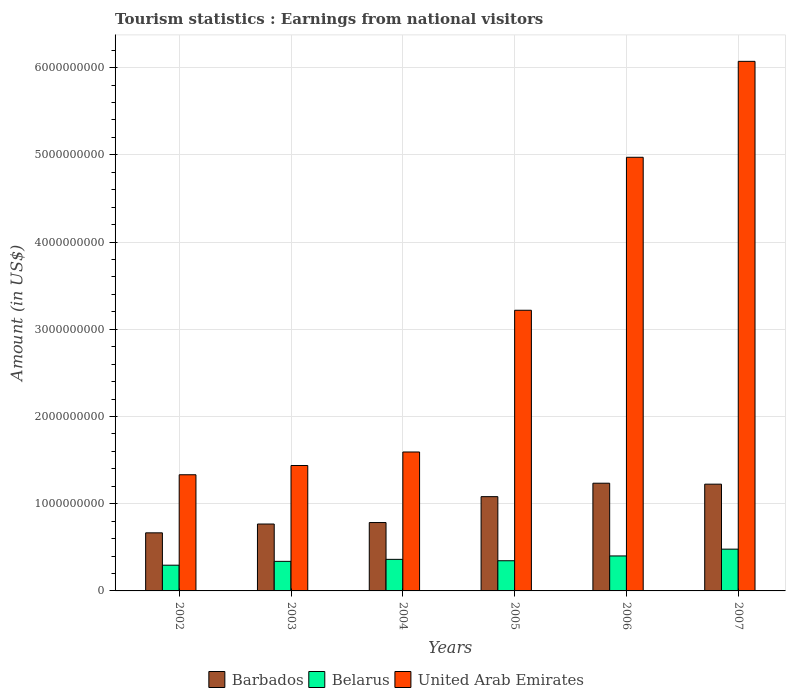How many groups of bars are there?
Give a very brief answer. 6. How many bars are there on the 6th tick from the right?
Offer a terse response. 3. What is the label of the 6th group of bars from the left?
Make the answer very short. 2007. In how many cases, is the number of bars for a given year not equal to the number of legend labels?
Provide a succinct answer. 0. What is the earnings from national visitors in United Arab Emirates in 2004?
Offer a terse response. 1.59e+09. Across all years, what is the maximum earnings from national visitors in Belarus?
Keep it short and to the point. 4.79e+08. Across all years, what is the minimum earnings from national visitors in United Arab Emirates?
Ensure brevity in your answer.  1.33e+09. What is the total earnings from national visitors in United Arab Emirates in the graph?
Make the answer very short. 1.86e+1. What is the difference between the earnings from national visitors in Barbados in 2002 and that in 2005?
Ensure brevity in your answer.  -4.15e+08. What is the difference between the earnings from national visitors in Barbados in 2007 and the earnings from national visitors in Belarus in 2005?
Your answer should be compact. 8.78e+08. What is the average earnings from national visitors in Belarus per year?
Give a very brief answer. 3.70e+08. In the year 2005, what is the difference between the earnings from national visitors in Belarus and earnings from national visitors in United Arab Emirates?
Your answer should be very brief. -2.87e+09. What is the ratio of the earnings from national visitors in United Arab Emirates in 2004 to that in 2007?
Your answer should be very brief. 0.26. Is the earnings from national visitors in United Arab Emirates in 2002 less than that in 2007?
Ensure brevity in your answer.  Yes. Is the difference between the earnings from national visitors in Belarus in 2003 and 2005 greater than the difference between the earnings from national visitors in United Arab Emirates in 2003 and 2005?
Make the answer very short. Yes. What is the difference between the highest and the second highest earnings from national visitors in Belarus?
Your response must be concise. 7.80e+07. What is the difference between the highest and the lowest earnings from national visitors in United Arab Emirates?
Your response must be concise. 4.74e+09. In how many years, is the earnings from national visitors in Belarus greater than the average earnings from national visitors in Belarus taken over all years?
Your answer should be very brief. 2. Is the sum of the earnings from national visitors in Barbados in 2004 and 2007 greater than the maximum earnings from national visitors in United Arab Emirates across all years?
Provide a short and direct response. No. What does the 3rd bar from the left in 2007 represents?
Your answer should be very brief. United Arab Emirates. What does the 2nd bar from the right in 2003 represents?
Keep it short and to the point. Belarus. How many years are there in the graph?
Make the answer very short. 6. What is the difference between two consecutive major ticks on the Y-axis?
Offer a very short reply. 1.00e+09. Are the values on the major ticks of Y-axis written in scientific E-notation?
Offer a very short reply. No. Does the graph contain any zero values?
Provide a succinct answer. No. Does the graph contain grids?
Your answer should be compact. Yes. Where does the legend appear in the graph?
Ensure brevity in your answer.  Bottom center. How many legend labels are there?
Offer a terse response. 3. How are the legend labels stacked?
Your answer should be compact. Horizontal. What is the title of the graph?
Provide a succinct answer. Tourism statistics : Earnings from national visitors. What is the Amount (in US$) of Barbados in 2002?
Provide a short and direct response. 6.66e+08. What is the Amount (in US$) of Belarus in 2002?
Ensure brevity in your answer.  2.95e+08. What is the Amount (in US$) in United Arab Emirates in 2002?
Offer a very short reply. 1.33e+09. What is the Amount (in US$) of Barbados in 2003?
Keep it short and to the point. 7.67e+08. What is the Amount (in US$) of Belarus in 2003?
Offer a terse response. 3.39e+08. What is the Amount (in US$) in United Arab Emirates in 2003?
Your response must be concise. 1.44e+09. What is the Amount (in US$) in Barbados in 2004?
Give a very brief answer. 7.84e+08. What is the Amount (in US$) in Belarus in 2004?
Your answer should be compact. 3.62e+08. What is the Amount (in US$) of United Arab Emirates in 2004?
Offer a terse response. 1.59e+09. What is the Amount (in US$) in Barbados in 2005?
Make the answer very short. 1.08e+09. What is the Amount (in US$) of Belarus in 2005?
Your answer should be very brief. 3.46e+08. What is the Amount (in US$) of United Arab Emirates in 2005?
Your response must be concise. 3.22e+09. What is the Amount (in US$) of Barbados in 2006?
Provide a succinct answer. 1.24e+09. What is the Amount (in US$) of Belarus in 2006?
Your answer should be compact. 4.01e+08. What is the Amount (in US$) in United Arab Emirates in 2006?
Provide a short and direct response. 4.97e+09. What is the Amount (in US$) of Barbados in 2007?
Your response must be concise. 1.22e+09. What is the Amount (in US$) in Belarus in 2007?
Your answer should be compact. 4.79e+08. What is the Amount (in US$) in United Arab Emirates in 2007?
Give a very brief answer. 6.07e+09. Across all years, what is the maximum Amount (in US$) of Barbados?
Provide a succinct answer. 1.24e+09. Across all years, what is the maximum Amount (in US$) in Belarus?
Ensure brevity in your answer.  4.79e+08. Across all years, what is the maximum Amount (in US$) in United Arab Emirates?
Make the answer very short. 6.07e+09. Across all years, what is the minimum Amount (in US$) of Barbados?
Offer a very short reply. 6.66e+08. Across all years, what is the minimum Amount (in US$) of Belarus?
Offer a terse response. 2.95e+08. Across all years, what is the minimum Amount (in US$) in United Arab Emirates?
Your answer should be very brief. 1.33e+09. What is the total Amount (in US$) of Barbados in the graph?
Your answer should be compact. 5.76e+09. What is the total Amount (in US$) of Belarus in the graph?
Ensure brevity in your answer.  2.22e+09. What is the total Amount (in US$) of United Arab Emirates in the graph?
Give a very brief answer. 1.86e+1. What is the difference between the Amount (in US$) in Barbados in 2002 and that in 2003?
Keep it short and to the point. -1.01e+08. What is the difference between the Amount (in US$) of Belarus in 2002 and that in 2003?
Your response must be concise. -4.40e+07. What is the difference between the Amount (in US$) of United Arab Emirates in 2002 and that in 2003?
Make the answer very short. -1.06e+08. What is the difference between the Amount (in US$) in Barbados in 2002 and that in 2004?
Provide a succinct answer. -1.18e+08. What is the difference between the Amount (in US$) of Belarus in 2002 and that in 2004?
Give a very brief answer. -6.70e+07. What is the difference between the Amount (in US$) in United Arab Emirates in 2002 and that in 2004?
Keep it short and to the point. -2.61e+08. What is the difference between the Amount (in US$) in Barbados in 2002 and that in 2005?
Your answer should be very brief. -4.15e+08. What is the difference between the Amount (in US$) of Belarus in 2002 and that in 2005?
Provide a short and direct response. -5.10e+07. What is the difference between the Amount (in US$) of United Arab Emirates in 2002 and that in 2005?
Your response must be concise. -1.89e+09. What is the difference between the Amount (in US$) of Barbados in 2002 and that in 2006?
Keep it short and to the point. -5.69e+08. What is the difference between the Amount (in US$) in Belarus in 2002 and that in 2006?
Ensure brevity in your answer.  -1.06e+08. What is the difference between the Amount (in US$) of United Arab Emirates in 2002 and that in 2006?
Your response must be concise. -3.64e+09. What is the difference between the Amount (in US$) in Barbados in 2002 and that in 2007?
Offer a very short reply. -5.58e+08. What is the difference between the Amount (in US$) of Belarus in 2002 and that in 2007?
Provide a short and direct response. -1.84e+08. What is the difference between the Amount (in US$) in United Arab Emirates in 2002 and that in 2007?
Offer a very short reply. -4.74e+09. What is the difference between the Amount (in US$) of Barbados in 2003 and that in 2004?
Ensure brevity in your answer.  -1.70e+07. What is the difference between the Amount (in US$) of Belarus in 2003 and that in 2004?
Your answer should be compact. -2.30e+07. What is the difference between the Amount (in US$) in United Arab Emirates in 2003 and that in 2004?
Your answer should be compact. -1.55e+08. What is the difference between the Amount (in US$) of Barbados in 2003 and that in 2005?
Make the answer very short. -3.14e+08. What is the difference between the Amount (in US$) of Belarus in 2003 and that in 2005?
Make the answer very short. -7.00e+06. What is the difference between the Amount (in US$) in United Arab Emirates in 2003 and that in 2005?
Give a very brief answer. -1.78e+09. What is the difference between the Amount (in US$) in Barbados in 2003 and that in 2006?
Your answer should be very brief. -4.68e+08. What is the difference between the Amount (in US$) in Belarus in 2003 and that in 2006?
Offer a terse response. -6.20e+07. What is the difference between the Amount (in US$) of United Arab Emirates in 2003 and that in 2006?
Provide a short and direct response. -3.53e+09. What is the difference between the Amount (in US$) of Barbados in 2003 and that in 2007?
Provide a succinct answer. -4.57e+08. What is the difference between the Amount (in US$) of Belarus in 2003 and that in 2007?
Provide a short and direct response. -1.40e+08. What is the difference between the Amount (in US$) of United Arab Emirates in 2003 and that in 2007?
Ensure brevity in your answer.  -4.63e+09. What is the difference between the Amount (in US$) of Barbados in 2004 and that in 2005?
Offer a terse response. -2.97e+08. What is the difference between the Amount (in US$) of Belarus in 2004 and that in 2005?
Provide a short and direct response. 1.60e+07. What is the difference between the Amount (in US$) of United Arab Emirates in 2004 and that in 2005?
Your response must be concise. -1.62e+09. What is the difference between the Amount (in US$) of Barbados in 2004 and that in 2006?
Keep it short and to the point. -4.51e+08. What is the difference between the Amount (in US$) of Belarus in 2004 and that in 2006?
Your response must be concise. -3.90e+07. What is the difference between the Amount (in US$) of United Arab Emirates in 2004 and that in 2006?
Your answer should be very brief. -3.38e+09. What is the difference between the Amount (in US$) of Barbados in 2004 and that in 2007?
Your response must be concise. -4.40e+08. What is the difference between the Amount (in US$) in Belarus in 2004 and that in 2007?
Make the answer very short. -1.17e+08. What is the difference between the Amount (in US$) of United Arab Emirates in 2004 and that in 2007?
Ensure brevity in your answer.  -4.48e+09. What is the difference between the Amount (in US$) of Barbados in 2005 and that in 2006?
Your response must be concise. -1.54e+08. What is the difference between the Amount (in US$) in Belarus in 2005 and that in 2006?
Provide a succinct answer. -5.50e+07. What is the difference between the Amount (in US$) of United Arab Emirates in 2005 and that in 2006?
Your answer should be compact. -1.75e+09. What is the difference between the Amount (in US$) of Barbados in 2005 and that in 2007?
Make the answer very short. -1.43e+08. What is the difference between the Amount (in US$) in Belarus in 2005 and that in 2007?
Make the answer very short. -1.33e+08. What is the difference between the Amount (in US$) in United Arab Emirates in 2005 and that in 2007?
Provide a short and direct response. -2.85e+09. What is the difference between the Amount (in US$) in Barbados in 2006 and that in 2007?
Ensure brevity in your answer.  1.10e+07. What is the difference between the Amount (in US$) in Belarus in 2006 and that in 2007?
Keep it short and to the point. -7.80e+07. What is the difference between the Amount (in US$) of United Arab Emirates in 2006 and that in 2007?
Offer a terse response. -1.10e+09. What is the difference between the Amount (in US$) in Barbados in 2002 and the Amount (in US$) in Belarus in 2003?
Offer a very short reply. 3.27e+08. What is the difference between the Amount (in US$) in Barbados in 2002 and the Amount (in US$) in United Arab Emirates in 2003?
Keep it short and to the point. -7.72e+08. What is the difference between the Amount (in US$) in Belarus in 2002 and the Amount (in US$) in United Arab Emirates in 2003?
Give a very brief answer. -1.14e+09. What is the difference between the Amount (in US$) of Barbados in 2002 and the Amount (in US$) of Belarus in 2004?
Keep it short and to the point. 3.04e+08. What is the difference between the Amount (in US$) in Barbados in 2002 and the Amount (in US$) in United Arab Emirates in 2004?
Ensure brevity in your answer.  -9.27e+08. What is the difference between the Amount (in US$) of Belarus in 2002 and the Amount (in US$) of United Arab Emirates in 2004?
Provide a short and direct response. -1.30e+09. What is the difference between the Amount (in US$) in Barbados in 2002 and the Amount (in US$) in Belarus in 2005?
Ensure brevity in your answer.  3.20e+08. What is the difference between the Amount (in US$) in Barbados in 2002 and the Amount (in US$) in United Arab Emirates in 2005?
Provide a short and direct response. -2.55e+09. What is the difference between the Amount (in US$) of Belarus in 2002 and the Amount (in US$) of United Arab Emirates in 2005?
Give a very brief answer. -2.92e+09. What is the difference between the Amount (in US$) of Barbados in 2002 and the Amount (in US$) of Belarus in 2006?
Your answer should be very brief. 2.65e+08. What is the difference between the Amount (in US$) in Barbados in 2002 and the Amount (in US$) in United Arab Emirates in 2006?
Your response must be concise. -4.31e+09. What is the difference between the Amount (in US$) in Belarus in 2002 and the Amount (in US$) in United Arab Emirates in 2006?
Provide a succinct answer. -4.68e+09. What is the difference between the Amount (in US$) in Barbados in 2002 and the Amount (in US$) in Belarus in 2007?
Provide a succinct answer. 1.87e+08. What is the difference between the Amount (in US$) in Barbados in 2002 and the Amount (in US$) in United Arab Emirates in 2007?
Provide a succinct answer. -5.41e+09. What is the difference between the Amount (in US$) in Belarus in 2002 and the Amount (in US$) in United Arab Emirates in 2007?
Your answer should be compact. -5.78e+09. What is the difference between the Amount (in US$) of Barbados in 2003 and the Amount (in US$) of Belarus in 2004?
Make the answer very short. 4.05e+08. What is the difference between the Amount (in US$) of Barbados in 2003 and the Amount (in US$) of United Arab Emirates in 2004?
Give a very brief answer. -8.26e+08. What is the difference between the Amount (in US$) in Belarus in 2003 and the Amount (in US$) in United Arab Emirates in 2004?
Your answer should be compact. -1.25e+09. What is the difference between the Amount (in US$) of Barbados in 2003 and the Amount (in US$) of Belarus in 2005?
Make the answer very short. 4.21e+08. What is the difference between the Amount (in US$) of Barbados in 2003 and the Amount (in US$) of United Arab Emirates in 2005?
Offer a terse response. -2.45e+09. What is the difference between the Amount (in US$) of Belarus in 2003 and the Amount (in US$) of United Arab Emirates in 2005?
Make the answer very short. -2.88e+09. What is the difference between the Amount (in US$) in Barbados in 2003 and the Amount (in US$) in Belarus in 2006?
Your answer should be very brief. 3.66e+08. What is the difference between the Amount (in US$) of Barbados in 2003 and the Amount (in US$) of United Arab Emirates in 2006?
Keep it short and to the point. -4.20e+09. What is the difference between the Amount (in US$) of Belarus in 2003 and the Amount (in US$) of United Arab Emirates in 2006?
Provide a short and direct response. -4.63e+09. What is the difference between the Amount (in US$) in Barbados in 2003 and the Amount (in US$) in Belarus in 2007?
Offer a terse response. 2.88e+08. What is the difference between the Amount (in US$) in Barbados in 2003 and the Amount (in US$) in United Arab Emirates in 2007?
Offer a terse response. -5.30e+09. What is the difference between the Amount (in US$) in Belarus in 2003 and the Amount (in US$) in United Arab Emirates in 2007?
Offer a very short reply. -5.73e+09. What is the difference between the Amount (in US$) in Barbados in 2004 and the Amount (in US$) in Belarus in 2005?
Make the answer very short. 4.38e+08. What is the difference between the Amount (in US$) in Barbados in 2004 and the Amount (in US$) in United Arab Emirates in 2005?
Offer a terse response. -2.43e+09. What is the difference between the Amount (in US$) in Belarus in 2004 and the Amount (in US$) in United Arab Emirates in 2005?
Keep it short and to the point. -2.86e+09. What is the difference between the Amount (in US$) in Barbados in 2004 and the Amount (in US$) in Belarus in 2006?
Provide a succinct answer. 3.83e+08. What is the difference between the Amount (in US$) of Barbados in 2004 and the Amount (in US$) of United Arab Emirates in 2006?
Provide a succinct answer. -4.19e+09. What is the difference between the Amount (in US$) of Belarus in 2004 and the Amount (in US$) of United Arab Emirates in 2006?
Your answer should be compact. -4.61e+09. What is the difference between the Amount (in US$) of Barbados in 2004 and the Amount (in US$) of Belarus in 2007?
Give a very brief answer. 3.05e+08. What is the difference between the Amount (in US$) in Barbados in 2004 and the Amount (in US$) in United Arab Emirates in 2007?
Offer a very short reply. -5.29e+09. What is the difference between the Amount (in US$) in Belarus in 2004 and the Amount (in US$) in United Arab Emirates in 2007?
Keep it short and to the point. -5.71e+09. What is the difference between the Amount (in US$) of Barbados in 2005 and the Amount (in US$) of Belarus in 2006?
Provide a short and direct response. 6.80e+08. What is the difference between the Amount (in US$) of Barbados in 2005 and the Amount (in US$) of United Arab Emirates in 2006?
Make the answer very short. -3.89e+09. What is the difference between the Amount (in US$) in Belarus in 2005 and the Amount (in US$) in United Arab Emirates in 2006?
Provide a succinct answer. -4.63e+09. What is the difference between the Amount (in US$) in Barbados in 2005 and the Amount (in US$) in Belarus in 2007?
Offer a very short reply. 6.02e+08. What is the difference between the Amount (in US$) of Barbados in 2005 and the Amount (in US$) of United Arab Emirates in 2007?
Make the answer very short. -4.99e+09. What is the difference between the Amount (in US$) in Belarus in 2005 and the Amount (in US$) in United Arab Emirates in 2007?
Your answer should be very brief. -5.73e+09. What is the difference between the Amount (in US$) in Barbados in 2006 and the Amount (in US$) in Belarus in 2007?
Provide a short and direct response. 7.56e+08. What is the difference between the Amount (in US$) in Barbados in 2006 and the Amount (in US$) in United Arab Emirates in 2007?
Give a very brief answer. -4.84e+09. What is the difference between the Amount (in US$) in Belarus in 2006 and the Amount (in US$) in United Arab Emirates in 2007?
Offer a terse response. -5.67e+09. What is the average Amount (in US$) of Barbados per year?
Your response must be concise. 9.60e+08. What is the average Amount (in US$) in Belarus per year?
Keep it short and to the point. 3.70e+08. What is the average Amount (in US$) in United Arab Emirates per year?
Give a very brief answer. 3.10e+09. In the year 2002, what is the difference between the Amount (in US$) in Barbados and Amount (in US$) in Belarus?
Offer a terse response. 3.71e+08. In the year 2002, what is the difference between the Amount (in US$) of Barbados and Amount (in US$) of United Arab Emirates?
Offer a terse response. -6.66e+08. In the year 2002, what is the difference between the Amount (in US$) in Belarus and Amount (in US$) in United Arab Emirates?
Give a very brief answer. -1.04e+09. In the year 2003, what is the difference between the Amount (in US$) in Barbados and Amount (in US$) in Belarus?
Your answer should be very brief. 4.28e+08. In the year 2003, what is the difference between the Amount (in US$) in Barbados and Amount (in US$) in United Arab Emirates?
Provide a succinct answer. -6.71e+08. In the year 2003, what is the difference between the Amount (in US$) of Belarus and Amount (in US$) of United Arab Emirates?
Make the answer very short. -1.10e+09. In the year 2004, what is the difference between the Amount (in US$) of Barbados and Amount (in US$) of Belarus?
Your answer should be compact. 4.22e+08. In the year 2004, what is the difference between the Amount (in US$) in Barbados and Amount (in US$) in United Arab Emirates?
Make the answer very short. -8.09e+08. In the year 2004, what is the difference between the Amount (in US$) of Belarus and Amount (in US$) of United Arab Emirates?
Your response must be concise. -1.23e+09. In the year 2005, what is the difference between the Amount (in US$) of Barbados and Amount (in US$) of Belarus?
Your response must be concise. 7.35e+08. In the year 2005, what is the difference between the Amount (in US$) in Barbados and Amount (in US$) in United Arab Emirates?
Give a very brief answer. -2.14e+09. In the year 2005, what is the difference between the Amount (in US$) of Belarus and Amount (in US$) of United Arab Emirates?
Make the answer very short. -2.87e+09. In the year 2006, what is the difference between the Amount (in US$) in Barbados and Amount (in US$) in Belarus?
Offer a very short reply. 8.34e+08. In the year 2006, what is the difference between the Amount (in US$) in Barbados and Amount (in US$) in United Arab Emirates?
Offer a terse response. -3.74e+09. In the year 2006, what is the difference between the Amount (in US$) in Belarus and Amount (in US$) in United Arab Emirates?
Offer a terse response. -4.57e+09. In the year 2007, what is the difference between the Amount (in US$) of Barbados and Amount (in US$) of Belarus?
Your answer should be compact. 7.45e+08. In the year 2007, what is the difference between the Amount (in US$) in Barbados and Amount (in US$) in United Arab Emirates?
Make the answer very short. -4.85e+09. In the year 2007, what is the difference between the Amount (in US$) of Belarus and Amount (in US$) of United Arab Emirates?
Keep it short and to the point. -5.59e+09. What is the ratio of the Amount (in US$) in Barbados in 2002 to that in 2003?
Provide a short and direct response. 0.87. What is the ratio of the Amount (in US$) in Belarus in 2002 to that in 2003?
Keep it short and to the point. 0.87. What is the ratio of the Amount (in US$) in United Arab Emirates in 2002 to that in 2003?
Give a very brief answer. 0.93. What is the ratio of the Amount (in US$) in Barbados in 2002 to that in 2004?
Your response must be concise. 0.85. What is the ratio of the Amount (in US$) in Belarus in 2002 to that in 2004?
Provide a short and direct response. 0.81. What is the ratio of the Amount (in US$) in United Arab Emirates in 2002 to that in 2004?
Provide a short and direct response. 0.84. What is the ratio of the Amount (in US$) of Barbados in 2002 to that in 2005?
Provide a short and direct response. 0.62. What is the ratio of the Amount (in US$) of Belarus in 2002 to that in 2005?
Your response must be concise. 0.85. What is the ratio of the Amount (in US$) of United Arab Emirates in 2002 to that in 2005?
Offer a terse response. 0.41. What is the ratio of the Amount (in US$) in Barbados in 2002 to that in 2006?
Keep it short and to the point. 0.54. What is the ratio of the Amount (in US$) in Belarus in 2002 to that in 2006?
Provide a short and direct response. 0.74. What is the ratio of the Amount (in US$) of United Arab Emirates in 2002 to that in 2006?
Give a very brief answer. 0.27. What is the ratio of the Amount (in US$) in Barbados in 2002 to that in 2007?
Provide a short and direct response. 0.54. What is the ratio of the Amount (in US$) in Belarus in 2002 to that in 2007?
Your answer should be compact. 0.62. What is the ratio of the Amount (in US$) in United Arab Emirates in 2002 to that in 2007?
Provide a succinct answer. 0.22. What is the ratio of the Amount (in US$) in Barbados in 2003 to that in 2004?
Make the answer very short. 0.98. What is the ratio of the Amount (in US$) in Belarus in 2003 to that in 2004?
Offer a very short reply. 0.94. What is the ratio of the Amount (in US$) in United Arab Emirates in 2003 to that in 2004?
Ensure brevity in your answer.  0.9. What is the ratio of the Amount (in US$) in Barbados in 2003 to that in 2005?
Make the answer very short. 0.71. What is the ratio of the Amount (in US$) of Belarus in 2003 to that in 2005?
Offer a very short reply. 0.98. What is the ratio of the Amount (in US$) of United Arab Emirates in 2003 to that in 2005?
Provide a succinct answer. 0.45. What is the ratio of the Amount (in US$) of Barbados in 2003 to that in 2006?
Ensure brevity in your answer.  0.62. What is the ratio of the Amount (in US$) of Belarus in 2003 to that in 2006?
Provide a short and direct response. 0.85. What is the ratio of the Amount (in US$) of United Arab Emirates in 2003 to that in 2006?
Make the answer very short. 0.29. What is the ratio of the Amount (in US$) in Barbados in 2003 to that in 2007?
Keep it short and to the point. 0.63. What is the ratio of the Amount (in US$) in Belarus in 2003 to that in 2007?
Ensure brevity in your answer.  0.71. What is the ratio of the Amount (in US$) of United Arab Emirates in 2003 to that in 2007?
Ensure brevity in your answer.  0.24. What is the ratio of the Amount (in US$) in Barbados in 2004 to that in 2005?
Give a very brief answer. 0.73. What is the ratio of the Amount (in US$) in Belarus in 2004 to that in 2005?
Your answer should be compact. 1.05. What is the ratio of the Amount (in US$) in United Arab Emirates in 2004 to that in 2005?
Ensure brevity in your answer.  0.49. What is the ratio of the Amount (in US$) of Barbados in 2004 to that in 2006?
Give a very brief answer. 0.63. What is the ratio of the Amount (in US$) of Belarus in 2004 to that in 2006?
Give a very brief answer. 0.9. What is the ratio of the Amount (in US$) in United Arab Emirates in 2004 to that in 2006?
Ensure brevity in your answer.  0.32. What is the ratio of the Amount (in US$) in Barbados in 2004 to that in 2007?
Offer a terse response. 0.64. What is the ratio of the Amount (in US$) of Belarus in 2004 to that in 2007?
Provide a succinct answer. 0.76. What is the ratio of the Amount (in US$) of United Arab Emirates in 2004 to that in 2007?
Provide a short and direct response. 0.26. What is the ratio of the Amount (in US$) of Barbados in 2005 to that in 2006?
Give a very brief answer. 0.88. What is the ratio of the Amount (in US$) in Belarus in 2005 to that in 2006?
Offer a terse response. 0.86. What is the ratio of the Amount (in US$) of United Arab Emirates in 2005 to that in 2006?
Offer a very short reply. 0.65. What is the ratio of the Amount (in US$) in Barbados in 2005 to that in 2007?
Keep it short and to the point. 0.88. What is the ratio of the Amount (in US$) in Belarus in 2005 to that in 2007?
Offer a terse response. 0.72. What is the ratio of the Amount (in US$) of United Arab Emirates in 2005 to that in 2007?
Offer a terse response. 0.53. What is the ratio of the Amount (in US$) in Belarus in 2006 to that in 2007?
Your response must be concise. 0.84. What is the ratio of the Amount (in US$) of United Arab Emirates in 2006 to that in 2007?
Make the answer very short. 0.82. What is the difference between the highest and the second highest Amount (in US$) in Barbados?
Your answer should be very brief. 1.10e+07. What is the difference between the highest and the second highest Amount (in US$) of Belarus?
Make the answer very short. 7.80e+07. What is the difference between the highest and the second highest Amount (in US$) in United Arab Emirates?
Keep it short and to the point. 1.10e+09. What is the difference between the highest and the lowest Amount (in US$) of Barbados?
Your answer should be compact. 5.69e+08. What is the difference between the highest and the lowest Amount (in US$) of Belarus?
Make the answer very short. 1.84e+08. What is the difference between the highest and the lowest Amount (in US$) of United Arab Emirates?
Offer a very short reply. 4.74e+09. 